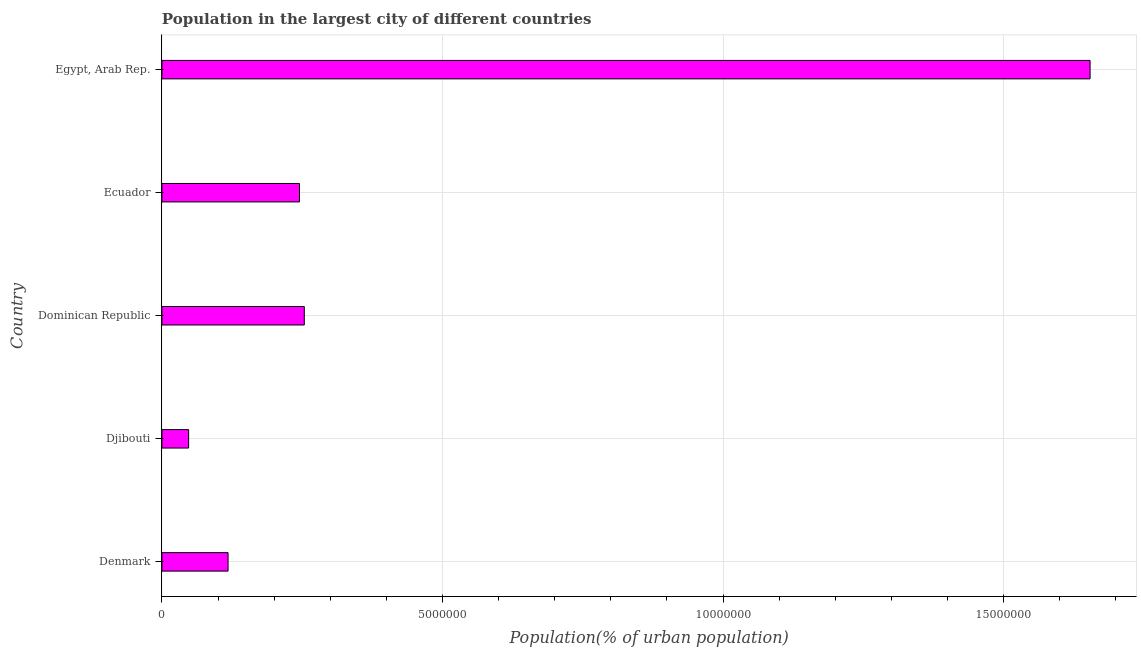Does the graph contain grids?
Provide a succinct answer. Yes. What is the title of the graph?
Provide a short and direct response. Population in the largest city of different countries. What is the label or title of the X-axis?
Keep it short and to the point. Population(% of urban population). What is the label or title of the Y-axis?
Make the answer very short. Country. What is the population in largest city in Dominican Republic?
Give a very brief answer. 2.54e+06. Across all countries, what is the maximum population in largest city?
Make the answer very short. 1.65e+07. Across all countries, what is the minimum population in largest city?
Ensure brevity in your answer.  4.76e+05. In which country was the population in largest city maximum?
Your answer should be very brief. Egypt, Arab Rep. In which country was the population in largest city minimum?
Provide a short and direct response. Djibouti. What is the sum of the population in largest city?
Provide a succinct answer. 2.32e+07. What is the difference between the population in largest city in Denmark and Ecuador?
Give a very brief answer. -1.27e+06. What is the average population in largest city per country?
Provide a short and direct response. 4.64e+06. What is the median population in largest city?
Your response must be concise. 2.45e+06. What is the ratio of the population in largest city in Djibouti to that in Ecuador?
Make the answer very short. 0.19. Is the population in largest city in Denmark less than that in Ecuador?
Make the answer very short. Yes. Is the difference between the population in largest city in Denmark and Djibouti greater than the difference between any two countries?
Offer a very short reply. No. What is the difference between the highest and the second highest population in largest city?
Give a very brief answer. 1.40e+07. What is the difference between the highest and the lowest population in largest city?
Your answer should be very brief. 1.61e+07. How many countries are there in the graph?
Your answer should be compact. 5. What is the Population(% of urban population) in Denmark?
Give a very brief answer. 1.18e+06. What is the Population(% of urban population) of Djibouti?
Offer a terse response. 4.76e+05. What is the Population(% of urban population) of Dominican Republic?
Your answer should be very brief. 2.54e+06. What is the Population(% of urban population) in Ecuador?
Provide a succinct answer. 2.45e+06. What is the Population(% of urban population) of Egypt, Arab Rep.?
Provide a succinct answer. 1.65e+07. What is the difference between the Population(% of urban population) in Denmark and Djibouti?
Your response must be concise. 7.03e+05. What is the difference between the Population(% of urban population) in Denmark and Dominican Republic?
Ensure brevity in your answer.  -1.36e+06. What is the difference between the Population(% of urban population) in Denmark and Ecuador?
Keep it short and to the point. -1.27e+06. What is the difference between the Population(% of urban population) in Denmark and Egypt, Arab Rep.?
Offer a very short reply. -1.54e+07. What is the difference between the Population(% of urban population) in Djibouti and Dominican Republic?
Your answer should be compact. -2.06e+06. What is the difference between the Population(% of urban population) in Djibouti and Ecuador?
Your answer should be very brief. -1.98e+06. What is the difference between the Population(% of urban population) in Djibouti and Egypt, Arab Rep.?
Your answer should be compact. -1.61e+07. What is the difference between the Population(% of urban population) in Dominican Republic and Ecuador?
Your answer should be very brief. 8.62e+04. What is the difference between the Population(% of urban population) in Dominican Republic and Egypt, Arab Rep.?
Provide a succinct answer. -1.40e+07. What is the difference between the Population(% of urban population) in Ecuador and Egypt, Arab Rep.?
Offer a very short reply. -1.41e+07. What is the ratio of the Population(% of urban population) in Denmark to that in Djibouti?
Your response must be concise. 2.48. What is the ratio of the Population(% of urban population) in Denmark to that in Dominican Republic?
Keep it short and to the point. 0.47. What is the ratio of the Population(% of urban population) in Denmark to that in Ecuador?
Make the answer very short. 0.48. What is the ratio of the Population(% of urban population) in Denmark to that in Egypt, Arab Rep.?
Give a very brief answer. 0.07. What is the ratio of the Population(% of urban population) in Djibouti to that in Dominican Republic?
Your response must be concise. 0.19. What is the ratio of the Population(% of urban population) in Djibouti to that in Ecuador?
Your answer should be compact. 0.19. What is the ratio of the Population(% of urban population) in Djibouti to that in Egypt, Arab Rep.?
Your response must be concise. 0.03. What is the ratio of the Population(% of urban population) in Dominican Republic to that in Ecuador?
Provide a short and direct response. 1.03. What is the ratio of the Population(% of urban population) in Dominican Republic to that in Egypt, Arab Rep.?
Provide a short and direct response. 0.15. What is the ratio of the Population(% of urban population) in Ecuador to that in Egypt, Arab Rep.?
Provide a succinct answer. 0.15. 